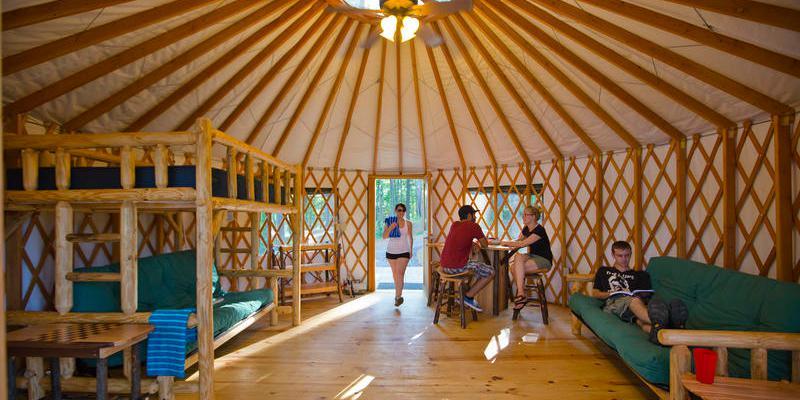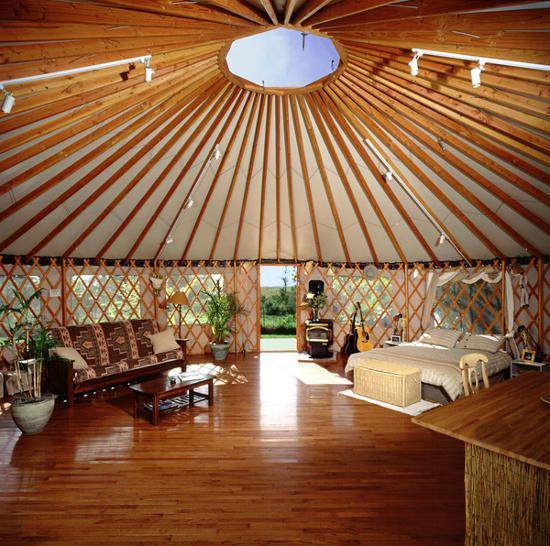The first image is the image on the left, the second image is the image on the right. Given the left and right images, does the statement "There is one fram on the wall in the image on the left" hold true? Answer yes or no. No. 